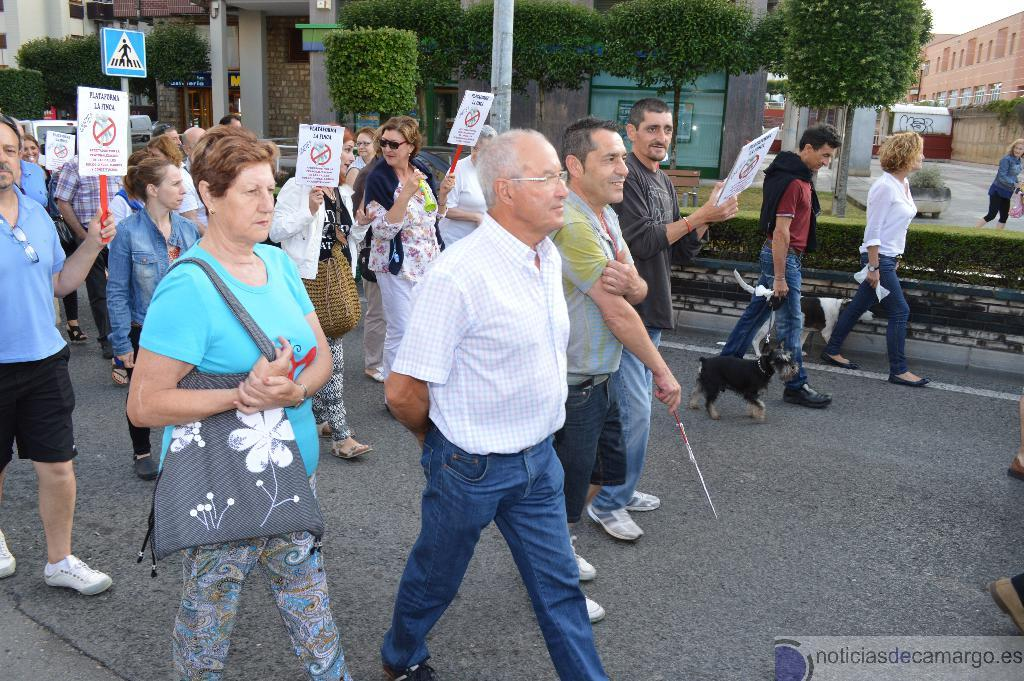What are the people in the image doing? People are walking on the road in the image. Is there any animal present in the image? Yes, there is a black dog present in the image. What are the people holding in their hands? The people are holding placards in their hands. What can be seen in the background of the image? There are trees and a building visible in the background. What type of creature can be seen swimming in the lake in the image? There is no lake present in the image, and therefore no creature can be seen swimming in it. What language are the people speaking in the image? The image does not provide any information about the language being spoken by the people. 